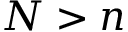<formula> <loc_0><loc_0><loc_500><loc_500>N > n</formula> 